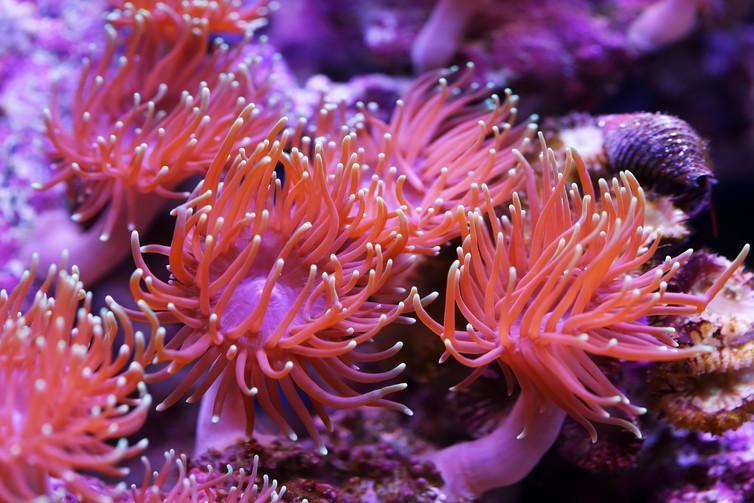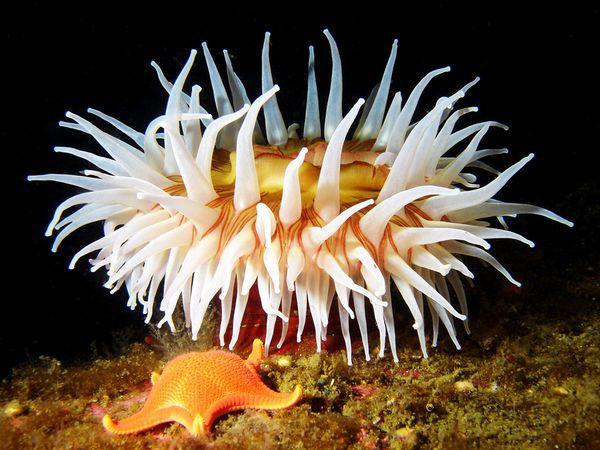The first image is the image on the left, the second image is the image on the right. Analyze the images presented: Is the assertion "The lefthand image contains an anemone with pink bits, the righthand image contains a mostly white anemone." valid? Answer yes or no. Yes. 